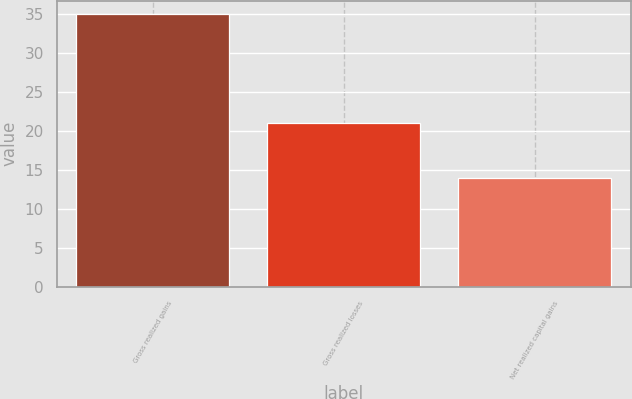<chart> <loc_0><loc_0><loc_500><loc_500><bar_chart><fcel>Gross realized gains<fcel>Gross realized losses<fcel>Net realized capital gains<nl><fcel>35<fcel>21<fcel>14<nl></chart> 